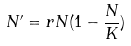Convert formula to latex. <formula><loc_0><loc_0><loc_500><loc_500>N ^ { \prime } = r N ( 1 - \frac { N } { K } )</formula> 